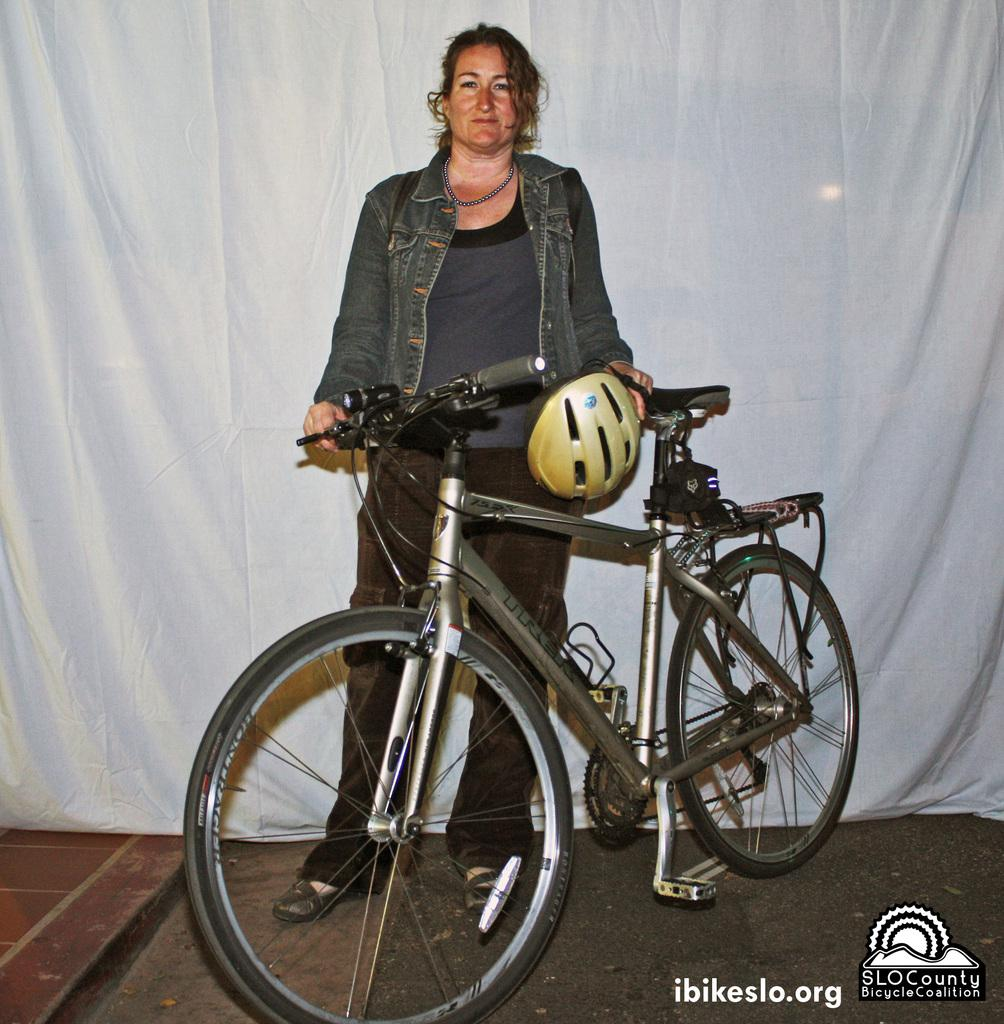What is in the foreground of the image? There is a cycle in the foreground of the image. Who is standing beside the cycle? A woman is standing beside the cycle. What is the woman holding? The woman is holding a helmet. What can be seen in the background of the image? There is a white curtain in the background of the image. What type of guide rod is visible in the image? There is no guide rod present in the image. 